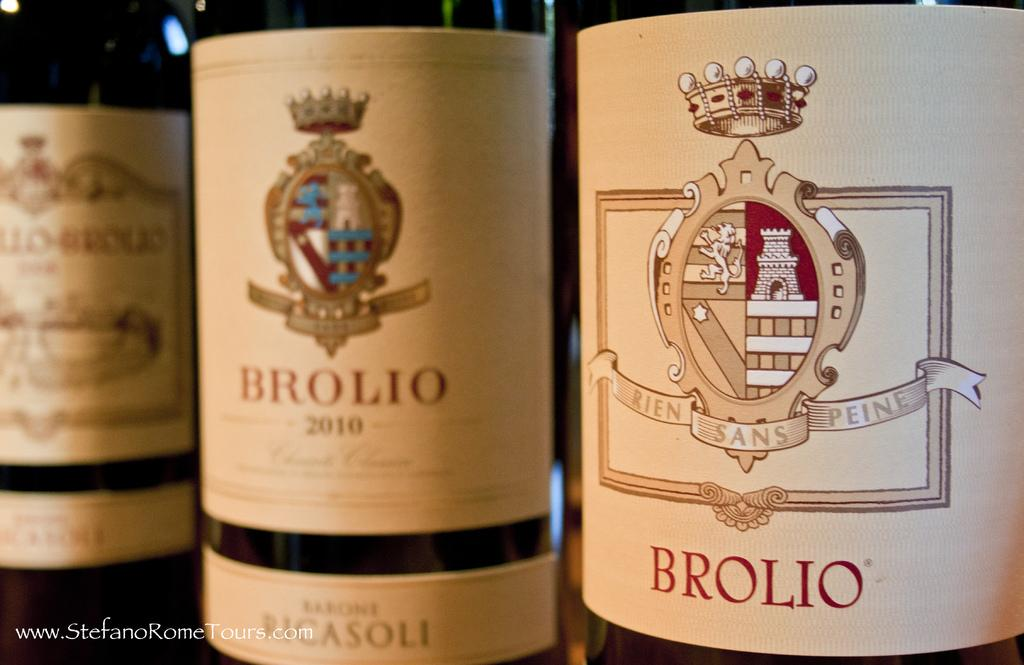Provide a one-sentence caption for the provided image. The bottles of Brolio wine, including one with a 2010 vintage, are stood up next to each other. 